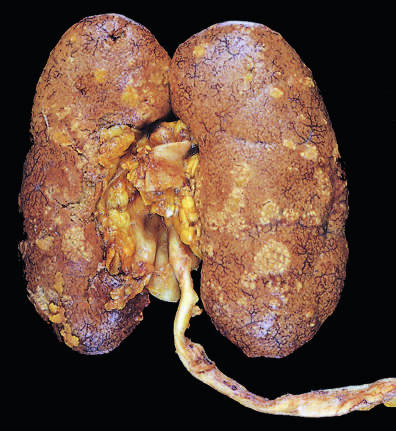s there dark congestion of the renal surface between the abscesses?
Answer the question using a single word or phrase. Yes 